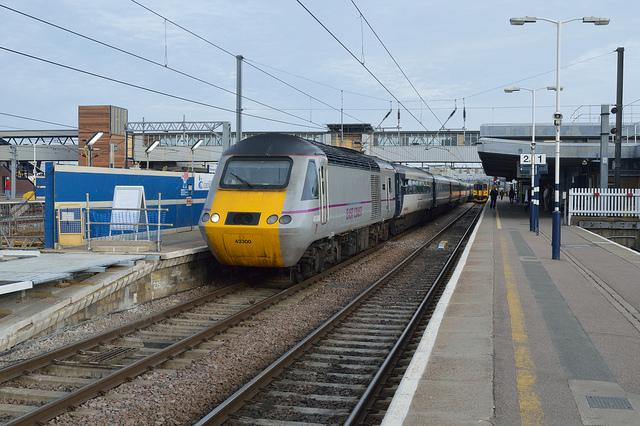Which train is safest to board for those on our right? right 